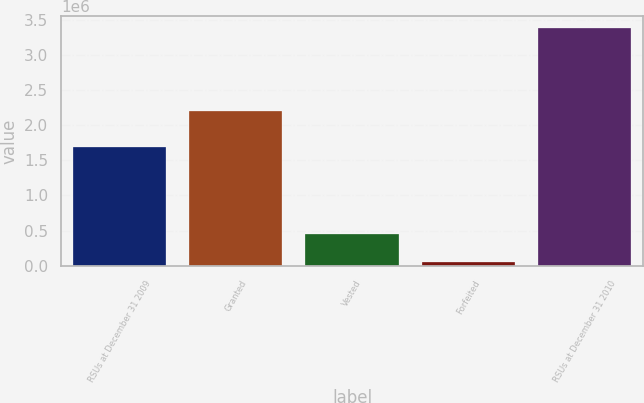Convert chart to OTSL. <chart><loc_0><loc_0><loc_500><loc_500><bar_chart><fcel>RSUs at December 31 2009<fcel>Granted<fcel>Vested<fcel>Forfeited<fcel>RSUs at December 31 2010<nl><fcel>1.68361e+06<fcel>2.20306e+06<fcel>455765<fcel>52065<fcel>3.37884e+06<nl></chart> 